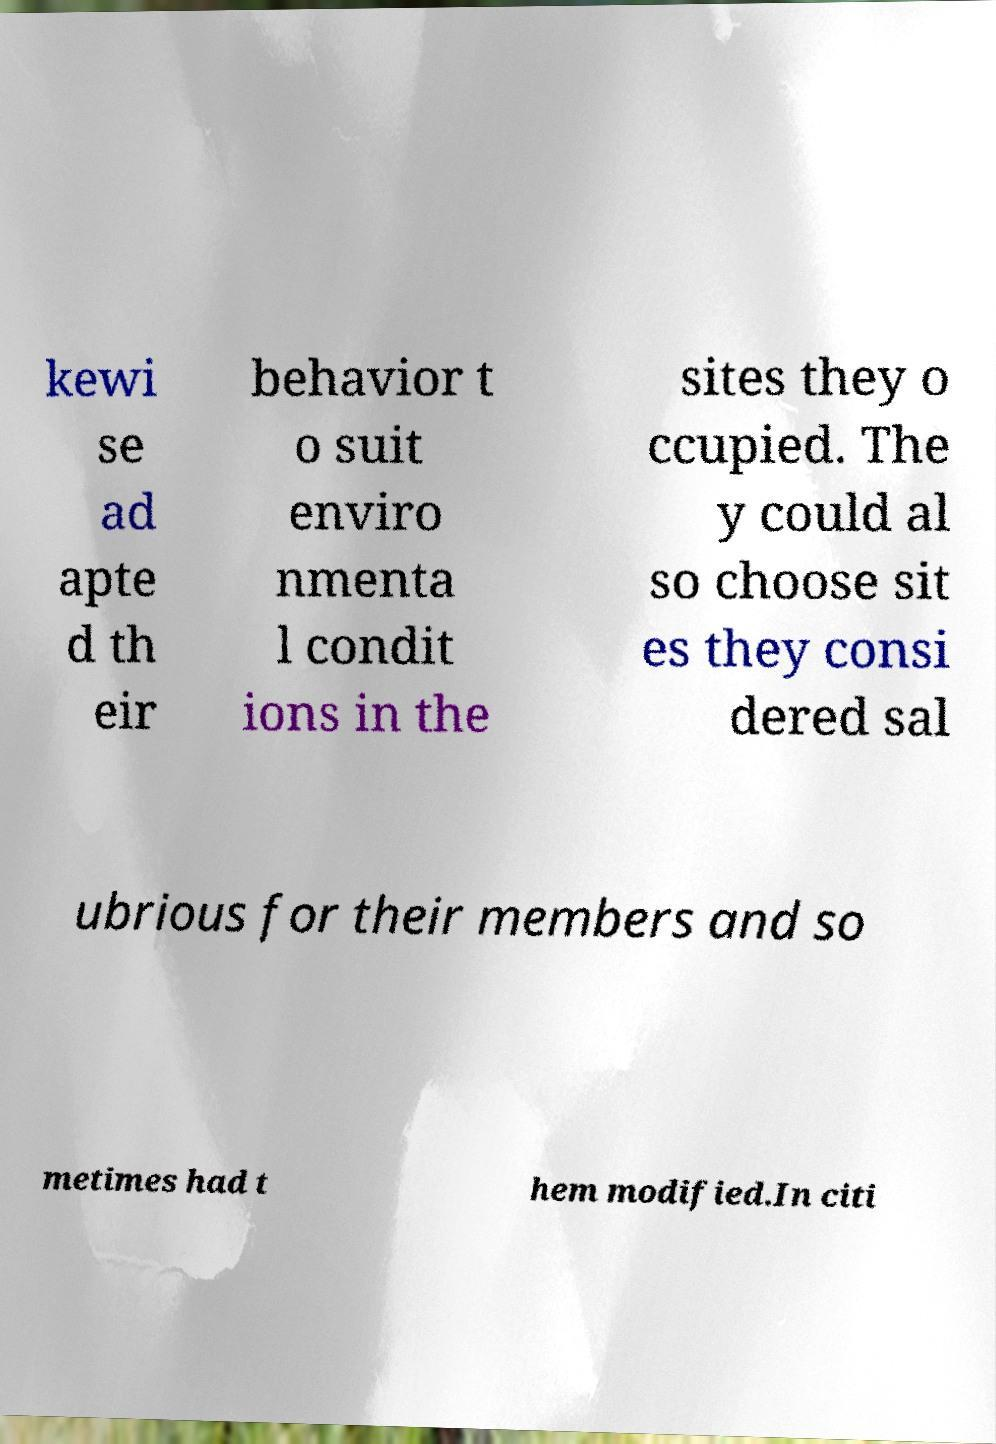Could you extract and type out the text from this image? kewi se ad apte d th eir behavior t o suit enviro nmenta l condit ions in the sites they o ccupied. The y could al so choose sit es they consi dered sal ubrious for their members and so metimes had t hem modified.In citi 